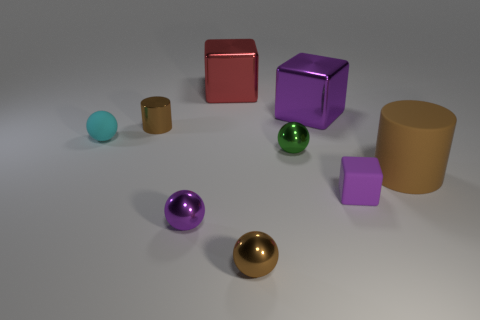What is the shape of the cyan object that is the same material as the large cylinder?
Offer a very short reply. Sphere. The tiny brown thing that is behind the brown cylinder that is right of the purple block that is in front of the cyan rubber thing is made of what material?
Make the answer very short. Metal. How many things are small matte things that are right of the tiny cyan thing or tiny green metallic spheres?
Provide a succinct answer. 2. What number of other things are the same shape as the tiny cyan matte thing?
Keep it short and to the point. 3. Are there more brown metal cylinders that are in front of the tiny brown metal ball than red cubes?
Your answer should be compact. No. There is a purple thing that is the same shape as the green thing; what is its size?
Your response must be concise. Small. Is there any other thing that has the same material as the big cylinder?
Your answer should be compact. Yes. There is a big purple thing; what shape is it?
Offer a very short reply. Cube. There is a cyan rubber object that is the same size as the purple sphere; what is its shape?
Offer a very short reply. Sphere. Is there any other thing of the same color as the large cylinder?
Give a very brief answer. Yes. 